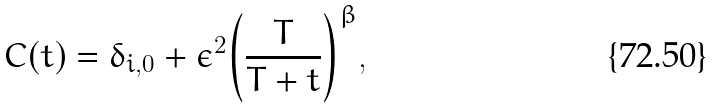Convert formula to latex. <formula><loc_0><loc_0><loc_500><loc_500>C ( t ) = \delta _ { i , 0 } + \epsilon ^ { 2 } { \left ( \frac { T } { T + t } \right ) } ^ { \beta } ,</formula> 